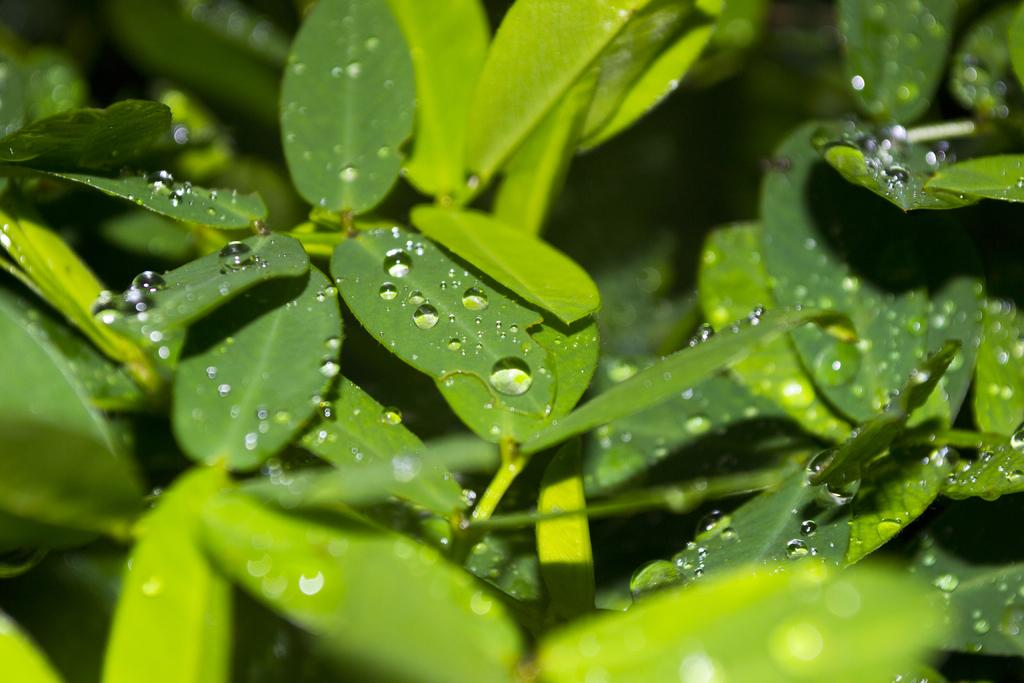What type of vegetation can be seen in the image? There are trees or plants in the image. Can you describe the condition of the plants? There are droplets of water on the leaves of the plants. What is the appearance of the background in the image? The background of the image is blurred. What type of advice can be seen written on the leaves of the plants in the image? There is no advice written on the leaves of the plants in the image. 